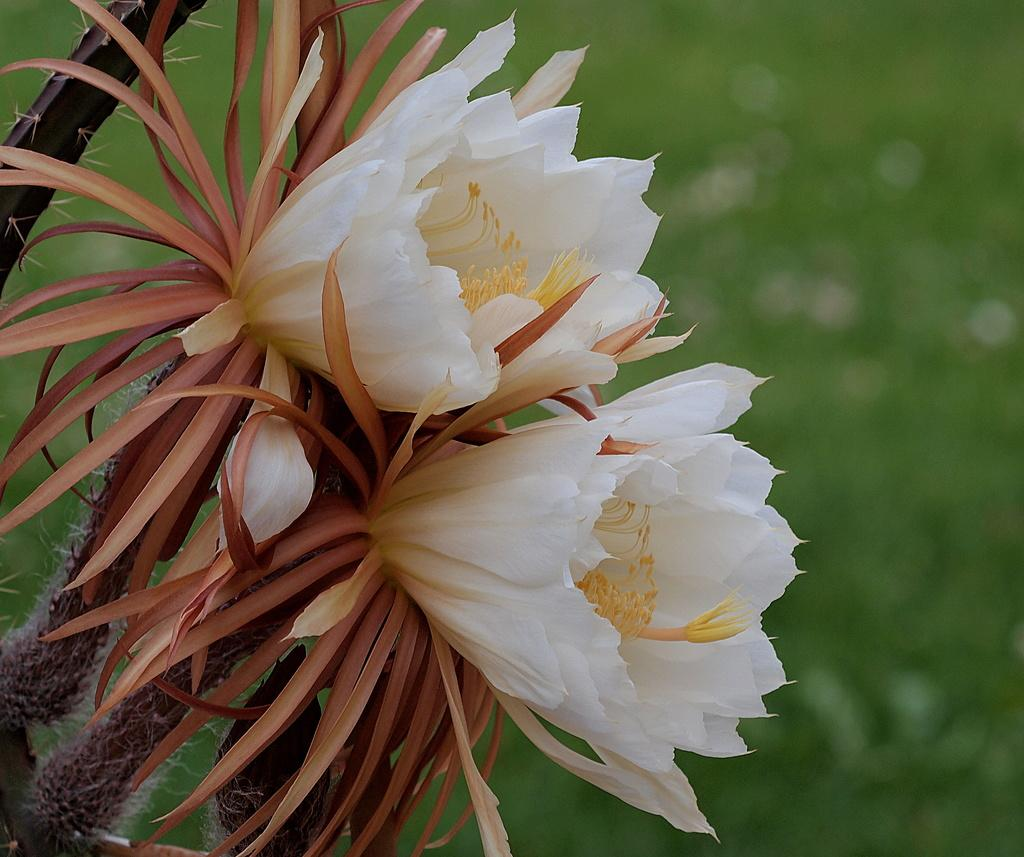What type of living organisms can be seen in the image? There are flowers in the image. What is located on the left side of the image? There is an object on the left side of the image. Can you describe the background of the image? The background of the image is blurred. What shape is the joke making in the image? There is no joke present in the image, so it cannot be making any shape. 